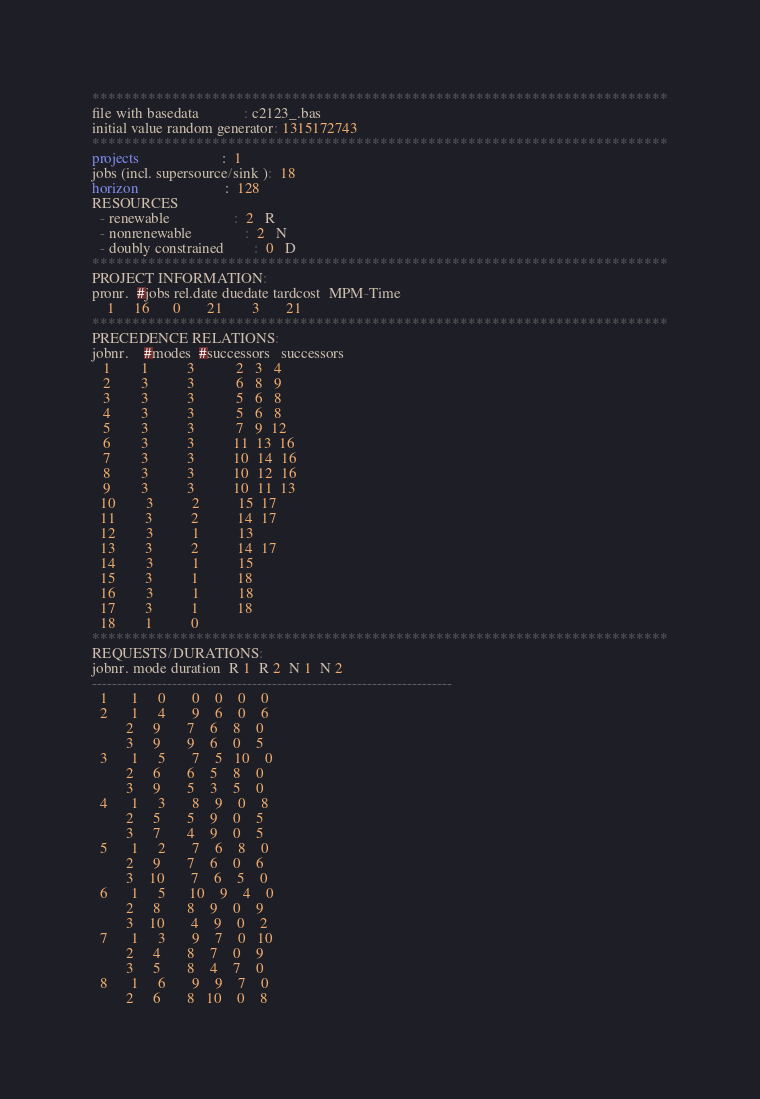<code> <loc_0><loc_0><loc_500><loc_500><_ObjectiveC_>************************************************************************
file with basedata            : c2123_.bas
initial value random generator: 1315172743
************************************************************************
projects                      :  1
jobs (incl. supersource/sink ):  18
horizon                       :  128
RESOURCES
  - renewable                 :  2   R
  - nonrenewable              :  2   N
  - doubly constrained        :  0   D
************************************************************************
PROJECT INFORMATION:
pronr.  #jobs rel.date duedate tardcost  MPM-Time
    1     16      0       21        3       21
************************************************************************
PRECEDENCE RELATIONS:
jobnr.    #modes  #successors   successors
   1        1          3           2   3   4
   2        3          3           6   8   9
   3        3          3           5   6   8
   4        3          3           5   6   8
   5        3          3           7   9  12
   6        3          3          11  13  16
   7        3          3          10  14  16
   8        3          3          10  12  16
   9        3          3          10  11  13
  10        3          2          15  17
  11        3          2          14  17
  12        3          1          13
  13        3          2          14  17
  14        3          1          15
  15        3          1          18
  16        3          1          18
  17        3          1          18
  18        1          0        
************************************************************************
REQUESTS/DURATIONS:
jobnr. mode duration  R 1  R 2  N 1  N 2
------------------------------------------------------------------------
  1      1     0       0    0    0    0
  2      1     4       9    6    0    6
         2     9       7    6    8    0
         3     9       9    6    0    5
  3      1     5       7    5   10    0
         2     6       6    5    8    0
         3     9       5    3    5    0
  4      1     3       8    9    0    8
         2     5       5    9    0    5
         3     7       4    9    0    5
  5      1     2       7    6    8    0
         2     9       7    6    0    6
         3    10       7    6    5    0
  6      1     5      10    9    4    0
         2     8       8    9    0    9
         3    10       4    9    0    2
  7      1     3       9    7    0   10
         2     4       8    7    0    9
         3     5       8    4    7    0
  8      1     6       9    9    7    0
         2     6       8   10    0    8</code> 